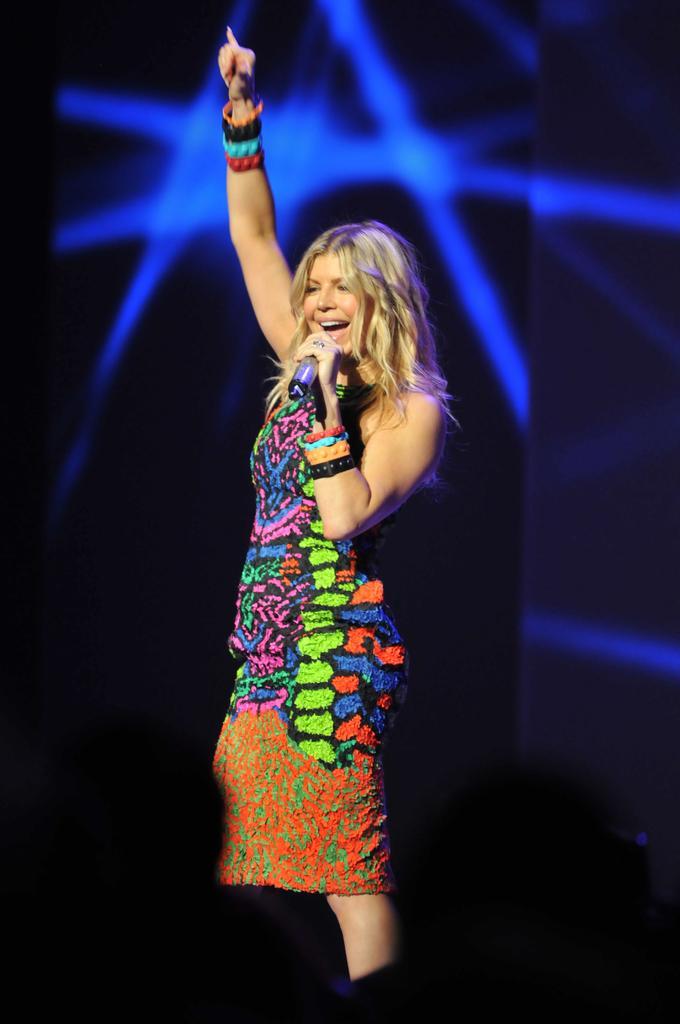How would you summarize this image in a sentence or two? There is a women who is talking on the mike and she is smiling. In the background there is a screen and this is floor. 